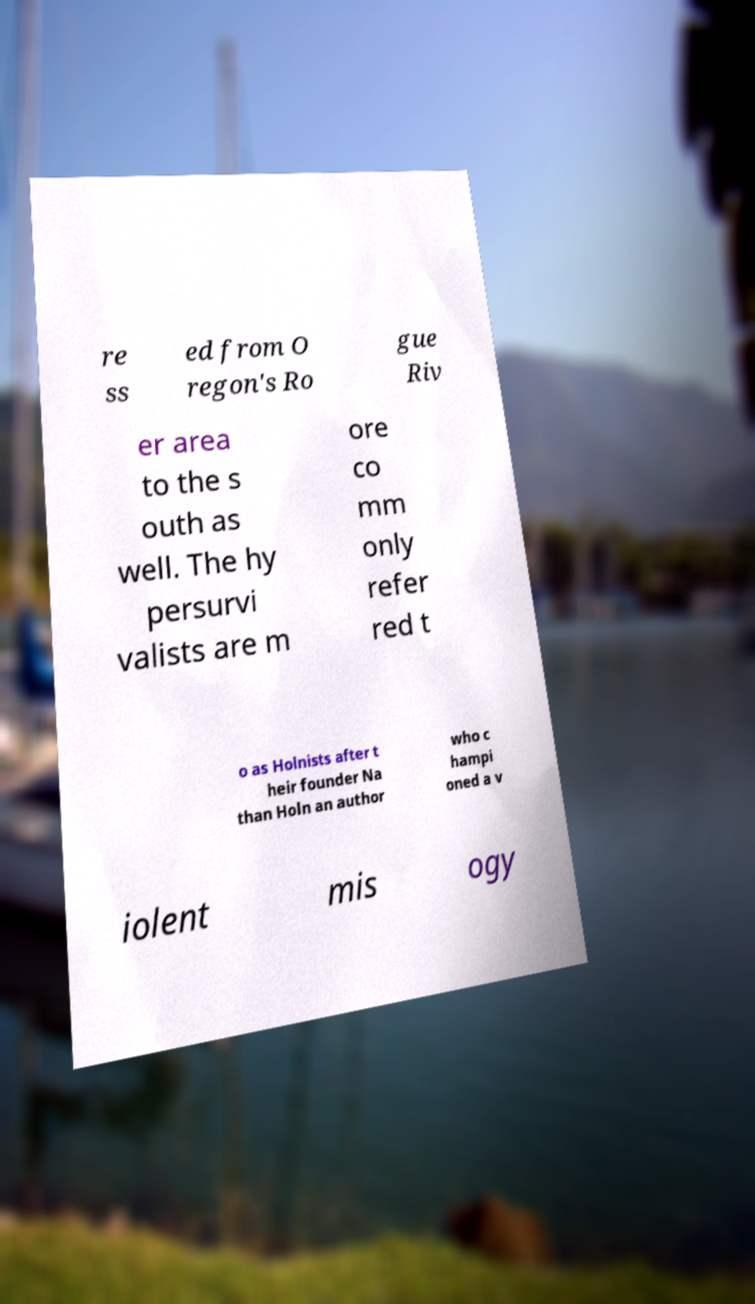Please identify and transcribe the text found in this image. re ss ed from O regon's Ro gue Riv er area to the s outh as well. The hy persurvi valists are m ore co mm only refer red t o as Holnists after t heir founder Na than Holn an author who c hampi oned a v iolent mis ogy 